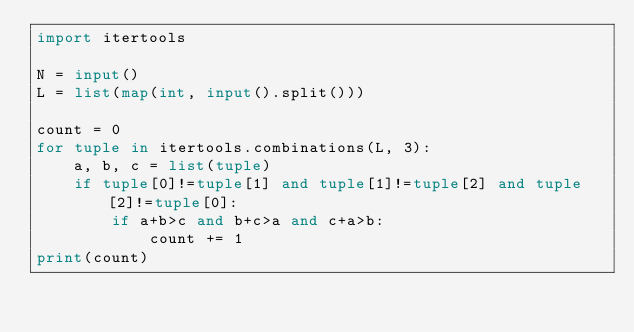<code> <loc_0><loc_0><loc_500><loc_500><_Python_>import itertools

N = input()
L = list(map(int, input().split()))

count = 0
for tuple in itertools.combinations(L, 3):
    a, b, c = list(tuple)
    if tuple[0]!=tuple[1] and tuple[1]!=tuple[2] and tuple[2]!=tuple[0]:
        if a+b>c and b+c>a and c+a>b:
            count += 1 
print(count)
</code> 